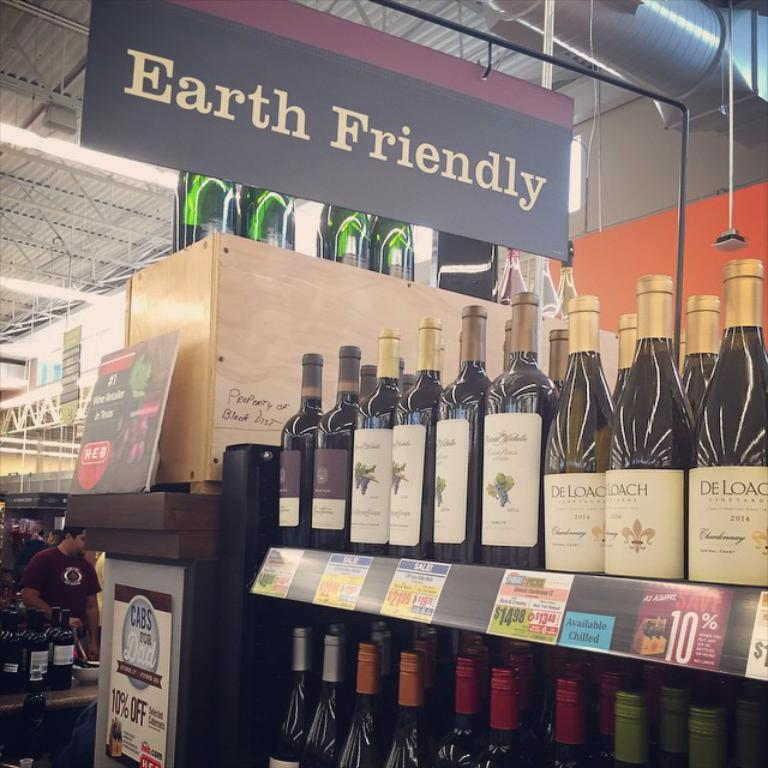<image>
Relay a brief, clear account of the picture shown. Many bottles of wine are on display in a store below a sign that says Earth Friendly. 